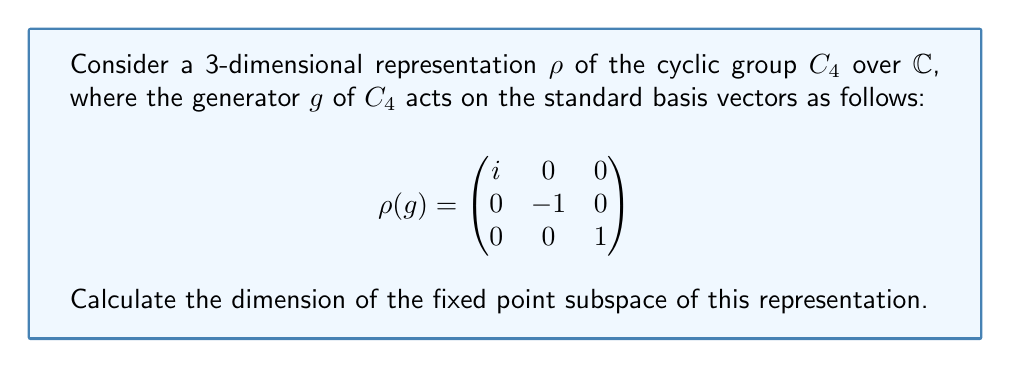Provide a solution to this math problem. Let's approach this step-by-step:

1) The fixed point subspace consists of all vectors $v$ such that $\rho(g)v = v$ for all $g \in C_4$.

2) Given that $g$ generates $C_4$, it's sufficient to find vectors $v$ such that $\rho(g)v = v$.

3) Let $v = (x, y, z)^T$ be a general vector in $\mathbb{C}^3$. We need to solve:

   $$\begin{pmatrix}
   i & 0 & 0 \\
   0 & -1 & 0 \\
   0 & 0 & 1
   \end{pmatrix} \begin{pmatrix} x \\ y \\ z \end{pmatrix} = \begin{pmatrix} x \\ y \\ z \end{pmatrix}$$

4) This gives us the system of equations:
   
   $ix = x$
   $-y = y$
   $z = z$

5) From the first equation: $ix = x \Rightarrow x(i-1) = 0 \Rightarrow x = 0$ (since $i \neq 1$)

6) From the second equation: $-y = y \Rightarrow 2y = 0 \Rightarrow y = 0$

7) The third equation is always satisfied for any $z$.

8) Therefore, the fixed point subspace consists of vectors of the form $(0, 0, z)$ where $z \in \mathbb{C}$.

9) This subspace is isomorphic to $\mathbb{C}$, which is 1-dimensional over $\mathbb{C}$.
Answer: 1 